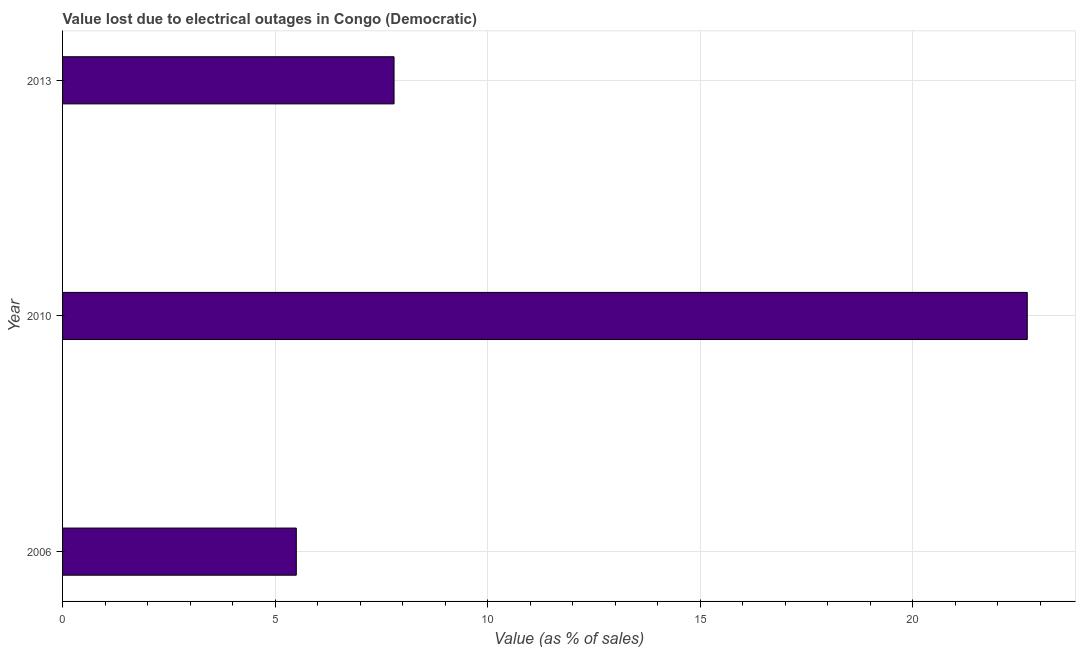What is the title of the graph?
Ensure brevity in your answer.  Value lost due to electrical outages in Congo (Democratic). What is the label or title of the X-axis?
Provide a short and direct response. Value (as % of sales). What is the value lost due to electrical outages in 2013?
Your answer should be compact. 7.8. Across all years, what is the maximum value lost due to electrical outages?
Your answer should be compact. 22.7. Across all years, what is the minimum value lost due to electrical outages?
Your response must be concise. 5.5. In which year was the value lost due to electrical outages maximum?
Make the answer very short. 2010. In which year was the value lost due to electrical outages minimum?
Provide a succinct answer. 2006. What is the average value lost due to electrical outages per year?
Your answer should be very brief. 12. Do a majority of the years between 2006 and 2013 (inclusive) have value lost due to electrical outages greater than 12 %?
Keep it short and to the point. No. What is the ratio of the value lost due to electrical outages in 2006 to that in 2013?
Your response must be concise. 0.7. What is the difference between the highest and the second highest value lost due to electrical outages?
Ensure brevity in your answer.  14.9. What is the difference between the highest and the lowest value lost due to electrical outages?
Provide a succinct answer. 17.2. In how many years, is the value lost due to electrical outages greater than the average value lost due to electrical outages taken over all years?
Ensure brevity in your answer.  1. How many bars are there?
Make the answer very short. 3. How many years are there in the graph?
Ensure brevity in your answer.  3. What is the difference between two consecutive major ticks on the X-axis?
Provide a succinct answer. 5. Are the values on the major ticks of X-axis written in scientific E-notation?
Offer a terse response. No. What is the Value (as % of sales) of 2006?
Provide a short and direct response. 5.5. What is the Value (as % of sales) in 2010?
Give a very brief answer. 22.7. What is the Value (as % of sales) in 2013?
Offer a very short reply. 7.8. What is the difference between the Value (as % of sales) in 2006 and 2010?
Give a very brief answer. -17.2. What is the difference between the Value (as % of sales) in 2010 and 2013?
Offer a terse response. 14.9. What is the ratio of the Value (as % of sales) in 2006 to that in 2010?
Offer a terse response. 0.24. What is the ratio of the Value (as % of sales) in 2006 to that in 2013?
Provide a short and direct response. 0.7. What is the ratio of the Value (as % of sales) in 2010 to that in 2013?
Offer a terse response. 2.91. 